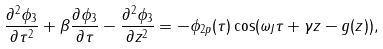Convert formula to latex. <formula><loc_0><loc_0><loc_500><loc_500>\frac { \partial ^ { 2 } \phi _ { 3 } } { \partial \tau ^ { 2 } } + \beta \frac { \partial \phi _ { 3 } } { \partial \tau } - \frac { \partial ^ { 2 } \phi _ { 3 } } { \partial z ^ { 2 } } = - \phi _ { 2 p } ( \tau ) \cos ( \omega _ { J } \tau + \gamma z - g ( z ) ) ,</formula> 